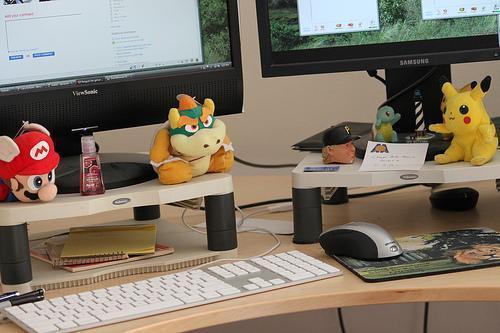How many keyboards are there?
Give a very brief answer. 1. How many computer screens are visible?
Give a very brief answer. 2. How many computer screens are on?
Give a very brief answer. 2. How many notebooks are on the desk?
Give a very brief answer. 3. How many yellow notebooks are there?
Give a very brief answer. 1. How many computer screens are in the photo?
Give a very brief answer. 2. 